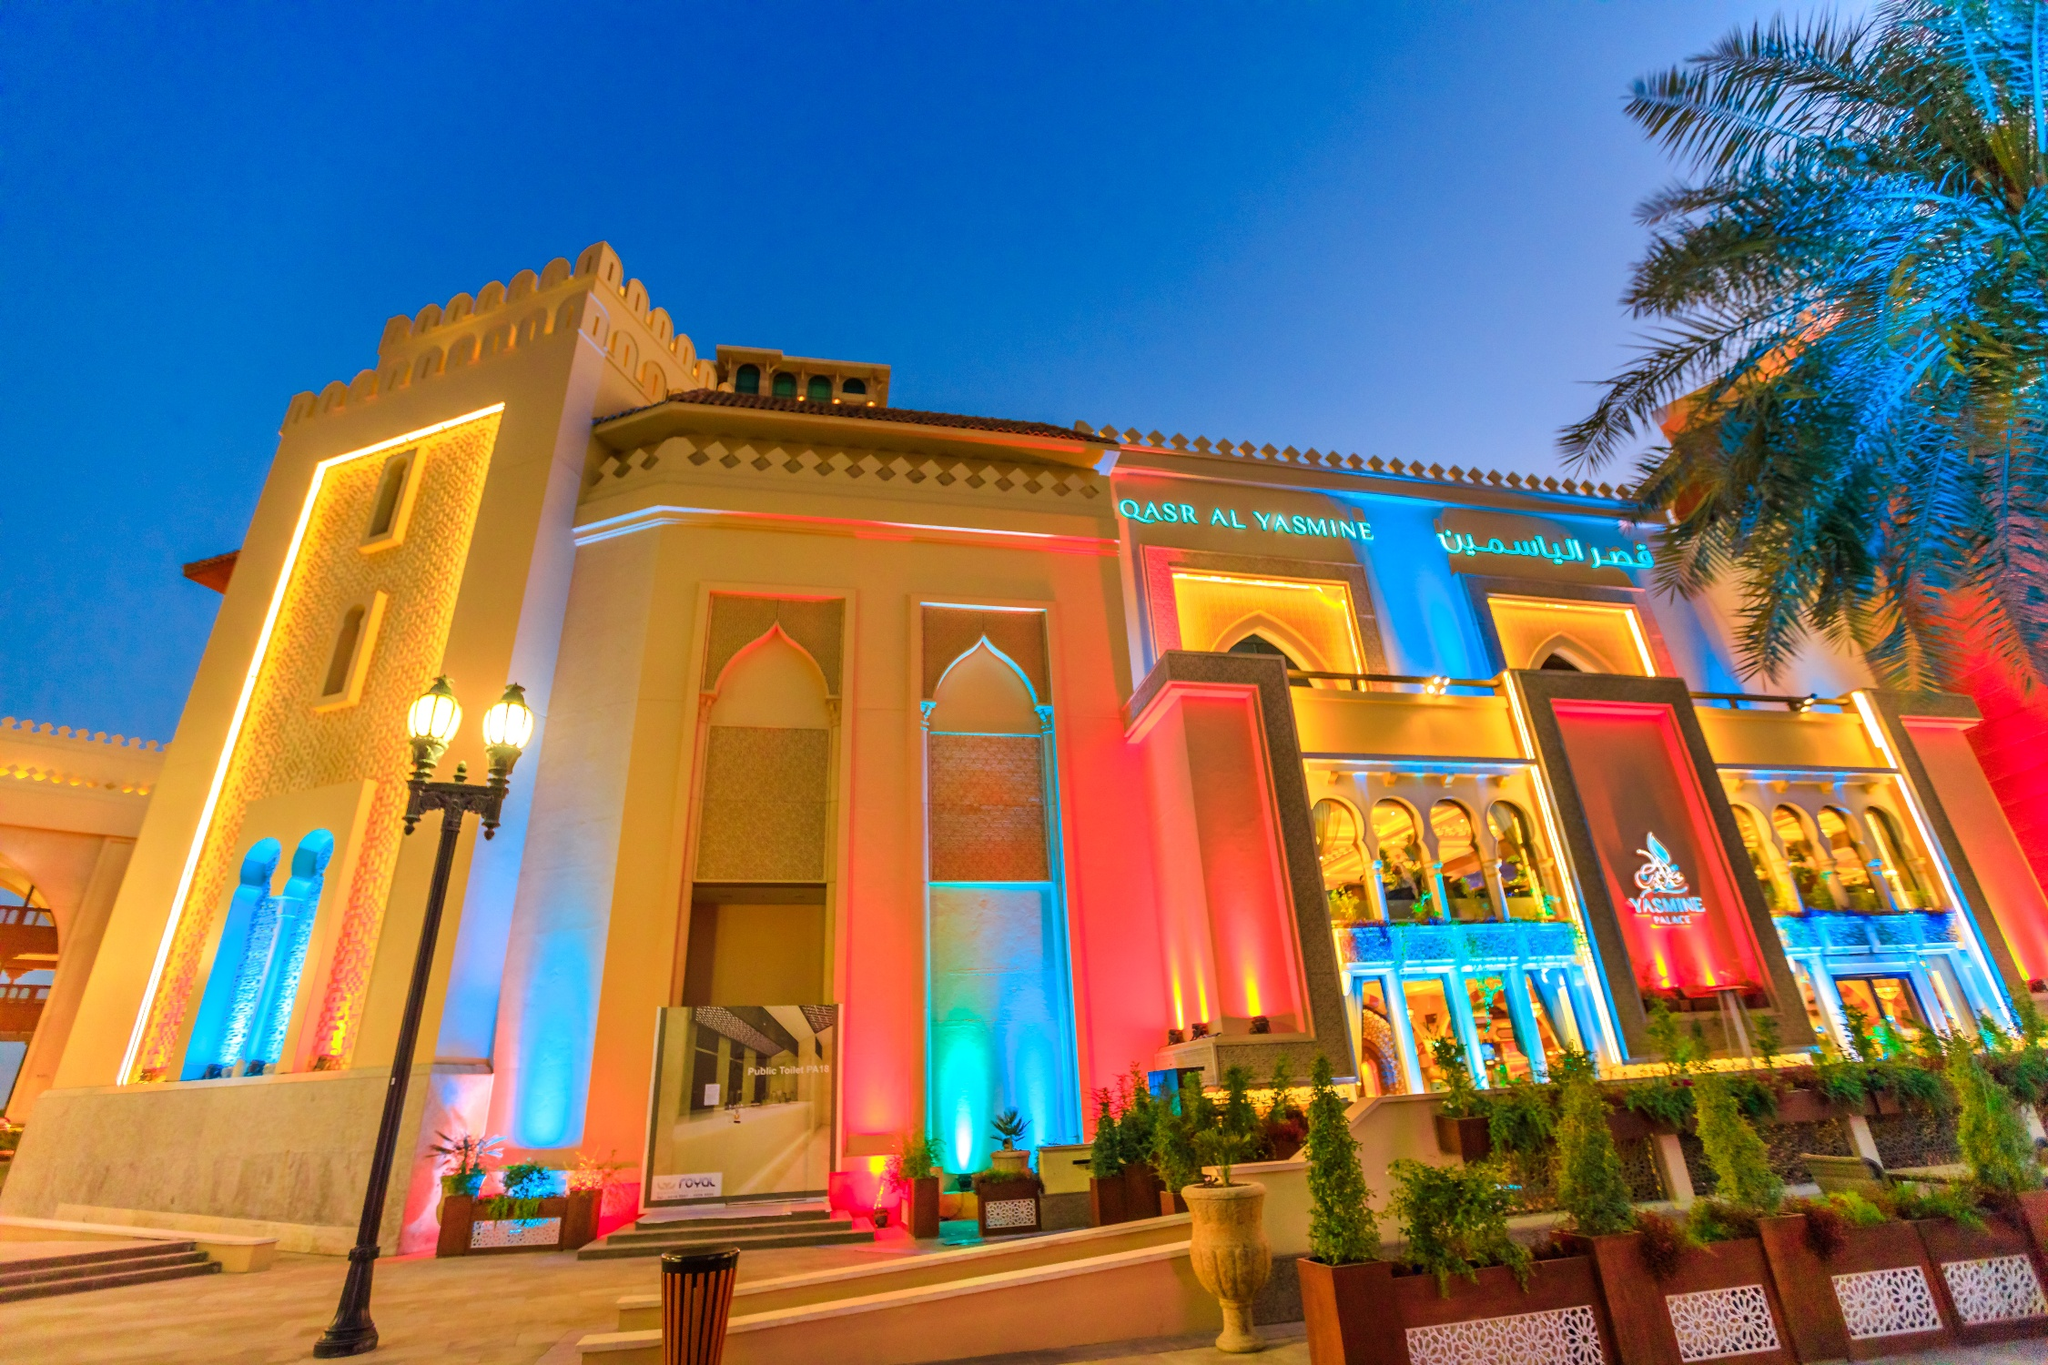Can you explain the architectural style of Qasr Al Watan? The architectural style of Qasr Al Watan is a modern reinterpretation of traditional Arabian design. It exhibits grand arches, geometric patterns, and majestic domes, all characteristic of Islamic architecture, yet incorporates advanced materials and engineering practices. This style not only respects the past but also embraces the present, forming a visual bridge between the history and future of Emirati architecture. 